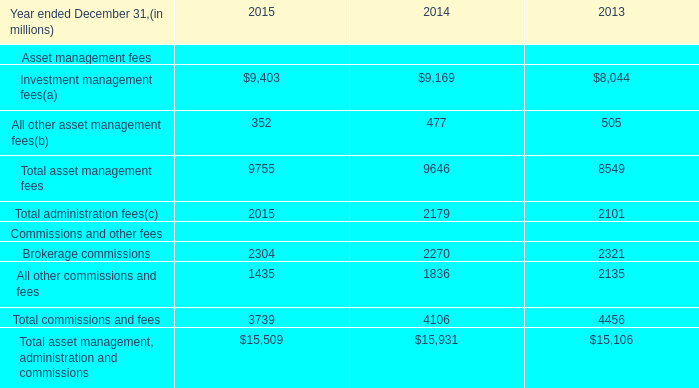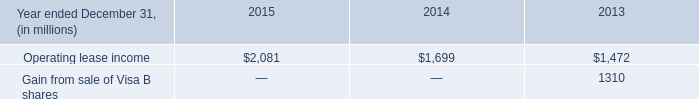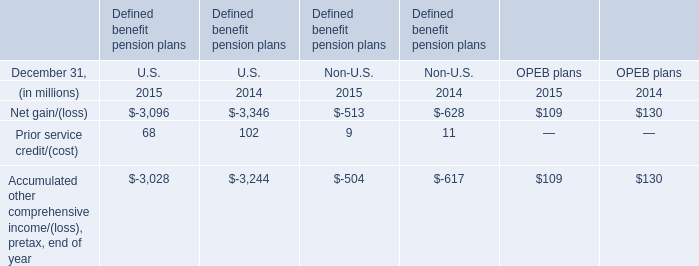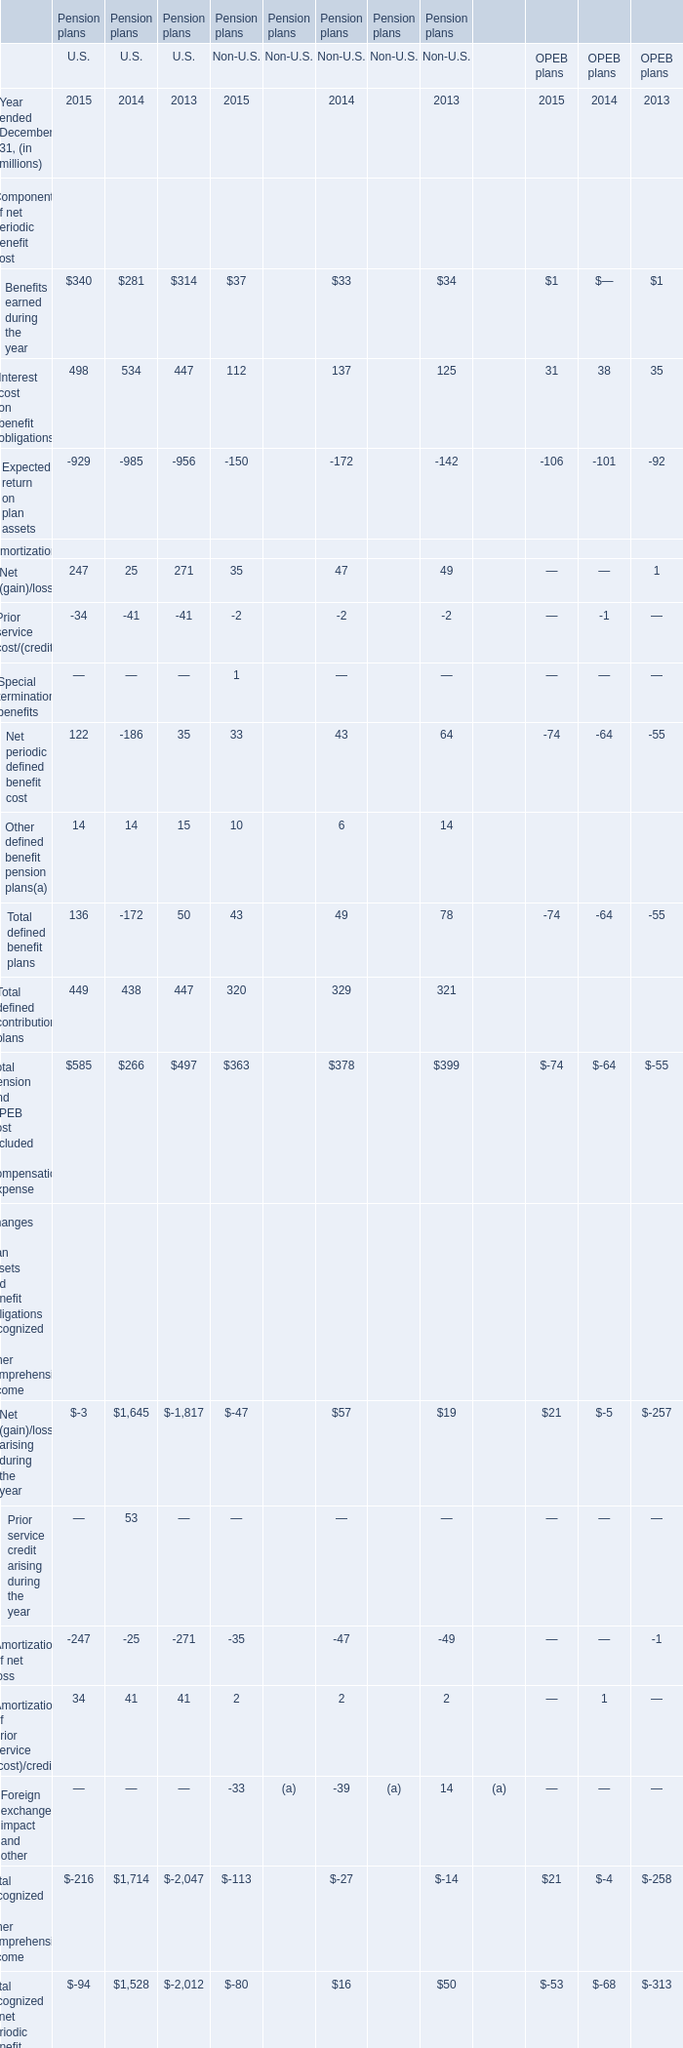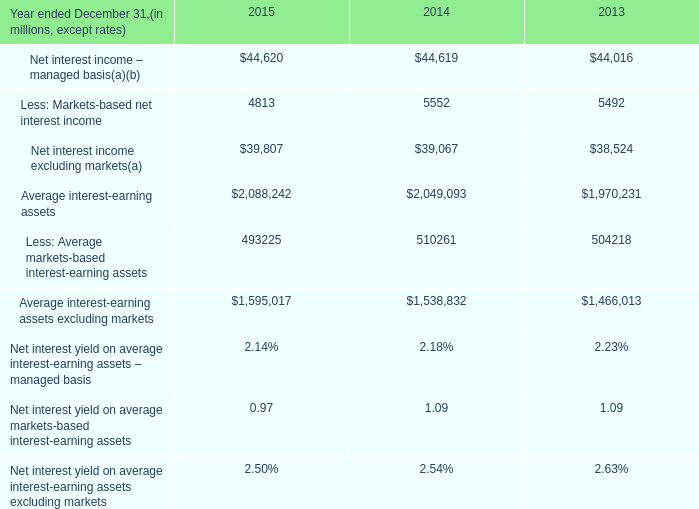What was the total amount of Non-U.S. in the range of 100 and 500 in 2014 ? (in million) 
Computations: (329 + 137)
Answer: 466.0. 